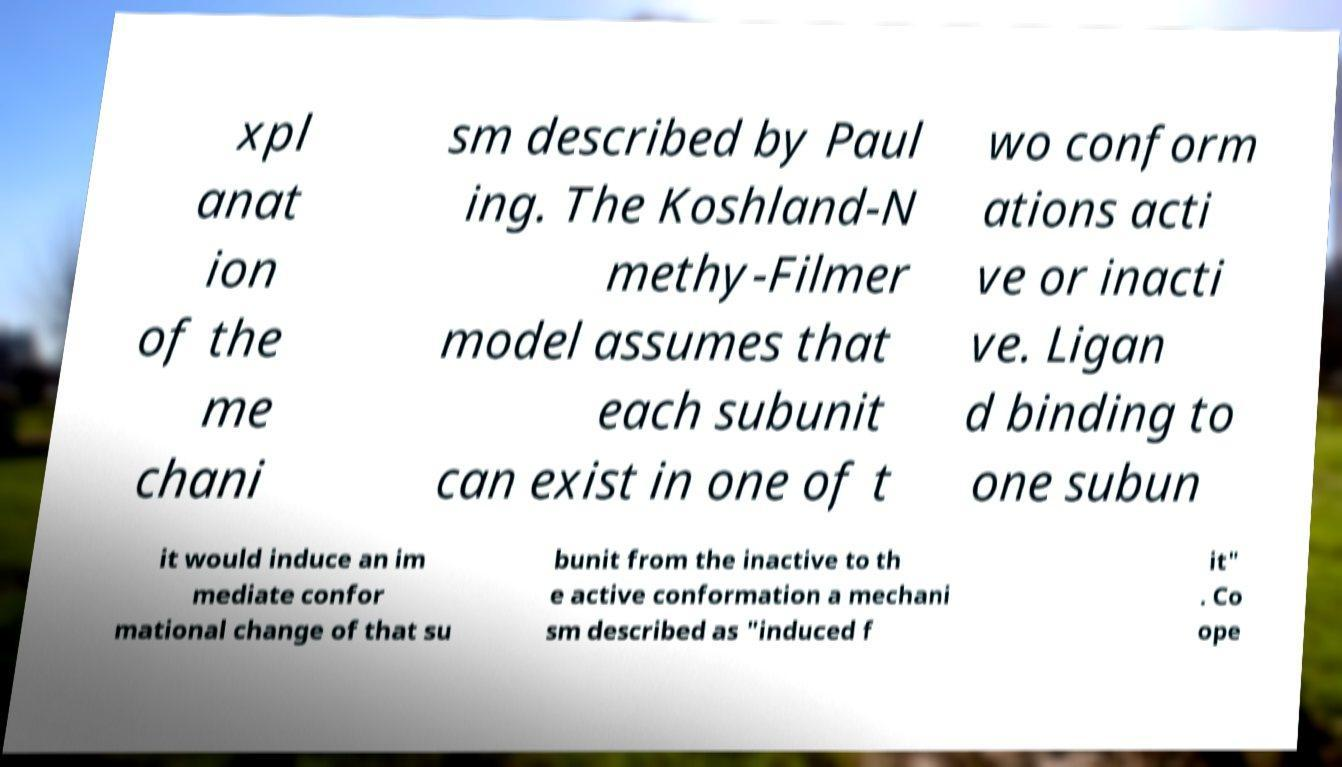What messages or text are displayed in this image? I need them in a readable, typed format. xpl anat ion of the me chani sm described by Paul ing. The Koshland-N methy-Filmer model assumes that each subunit can exist in one of t wo conform ations acti ve or inacti ve. Ligan d binding to one subun it would induce an im mediate confor mational change of that su bunit from the inactive to th e active conformation a mechani sm described as "induced f it" . Co ope 